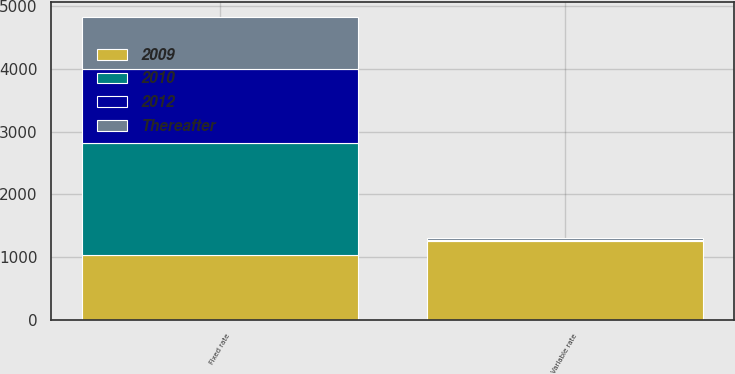<chart> <loc_0><loc_0><loc_500><loc_500><stacked_bar_chart><ecel><fcel>Fixed rate<fcel>Variable rate<nl><fcel>2009<fcel>1029<fcel>1249<nl><fcel>2012<fcel>1172<fcel>11<nl><fcel>2010<fcel>1796<fcel>14<nl><fcel>Thereafter<fcel>831<fcel>22<nl></chart> 